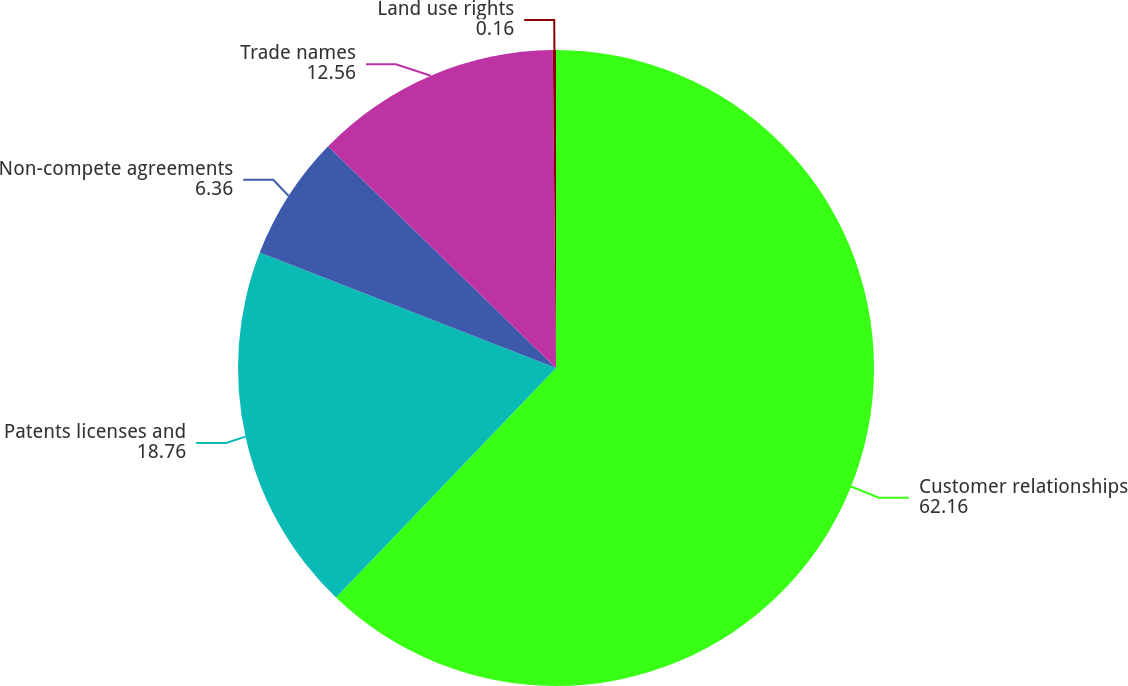Convert chart to OTSL. <chart><loc_0><loc_0><loc_500><loc_500><pie_chart><fcel>Customer relationships<fcel>Patents licenses and<fcel>Non-compete agreements<fcel>Trade names<fcel>Land use rights<nl><fcel>62.16%<fcel>18.76%<fcel>6.36%<fcel>12.56%<fcel>0.16%<nl></chart> 